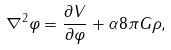Convert formula to latex. <formula><loc_0><loc_0><loc_500><loc_500>\nabla ^ { 2 } \varphi = \frac { \partial V } { \partial \varphi } + \alpha 8 \pi G \rho ,</formula> 